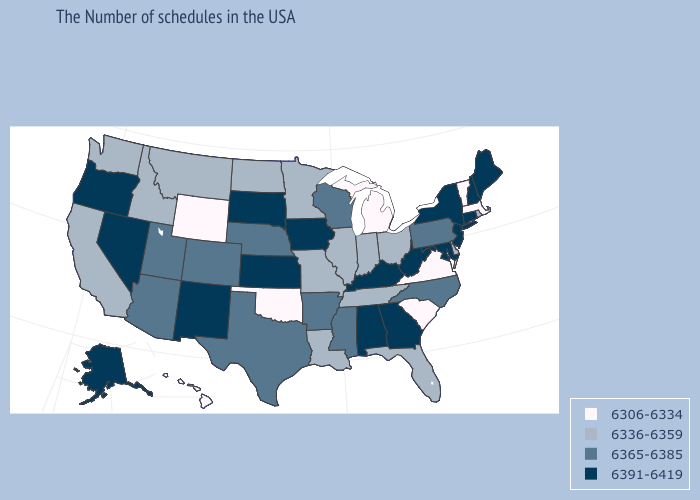What is the value of Rhode Island?
Be succinct. 6336-6359. Does Idaho have a lower value than Delaware?
Concise answer only. No. What is the highest value in states that border Utah?
Give a very brief answer. 6391-6419. Among the states that border Iowa , which have the highest value?
Be succinct. South Dakota. What is the value of Arizona?
Keep it brief. 6365-6385. Among the states that border Arkansas , which have the highest value?
Write a very short answer. Mississippi, Texas. What is the highest value in the MidWest ?
Quick response, please. 6391-6419. Name the states that have a value in the range 6391-6419?
Give a very brief answer. Maine, New Hampshire, Connecticut, New York, New Jersey, Maryland, West Virginia, Georgia, Kentucky, Alabama, Iowa, Kansas, South Dakota, New Mexico, Nevada, Oregon, Alaska. What is the highest value in states that border North Dakota?
Concise answer only. 6391-6419. Which states hav the highest value in the South?
Be succinct. Maryland, West Virginia, Georgia, Kentucky, Alabama. Which states have the lowest value in the USA?
Quick response, please. Massachusetts, Vermont, Virginia, South Carolina, Michigan, Oklahoma, Wyoming, Hawaii. Which states have the lowest value in the MidWest?
Short answer required. Michigan. What is the value of Nebraska?
Be succinct. 6365-6385. Which states have the lowest value in the USA?
Quick response, please. Massachusetts, Vermont, Virginia, South Carolina, Michigan, Oklahoma, Wyoming, Hawaii. Is the legend a continuous bar?
Short answer required. No. 